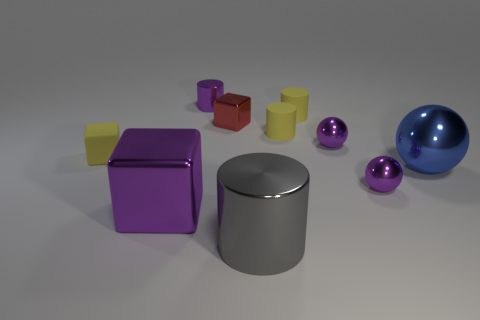How many yellow cylinders must be subtracted to get 1 yellow cylinders? 1 Subtract all cylinders. How many objects are left? 6 Subtract 0 brown cylinders. How many objects are left? 10 Subtract all tiny purple shiny cylinders. Subtract all purple balls. How many objects are left? 7 Add 1 tiny objects. How many tiny objects are left? 8 Add 10 large brown matte blocks. How many large brown matte blocks exist? 10 